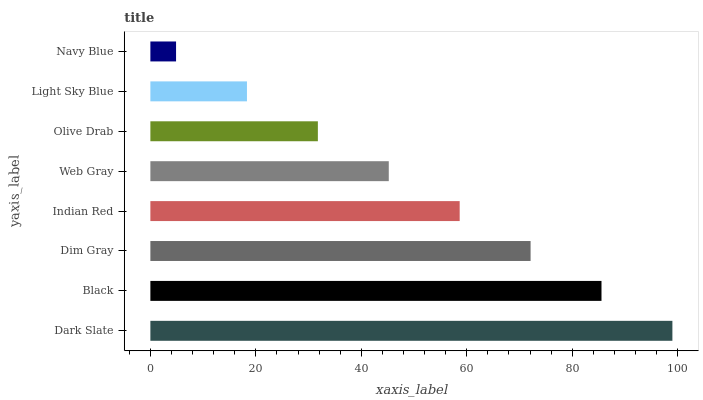Is Navy Blue the minimum?
Answer yes or no. Yes. Is Dark Slate the maximum?
Answer yes or no. Yes. Is Black the minimum?
Answer yes or no. No. Is Black the maximum?
Answer yes or no. No. Is Dark Slate greater than Black?
Answer yes or no. Yes. Is Black less than Dark Slate?
Answer yes or no. Yes. Is Black greater than Dark Slate?
Answer yes or no. No. Is Dark Slate less than Black?
Answer yes or no. No. Is Indian Red the high median?
Answer yes or no. Yes. Is Web Gray the low median?
Answer yes or no. Yes. Is Navy Blue the high median?
Answer yes or no. No. Is Dim Gray the low median?
Answer yes or no. No. 